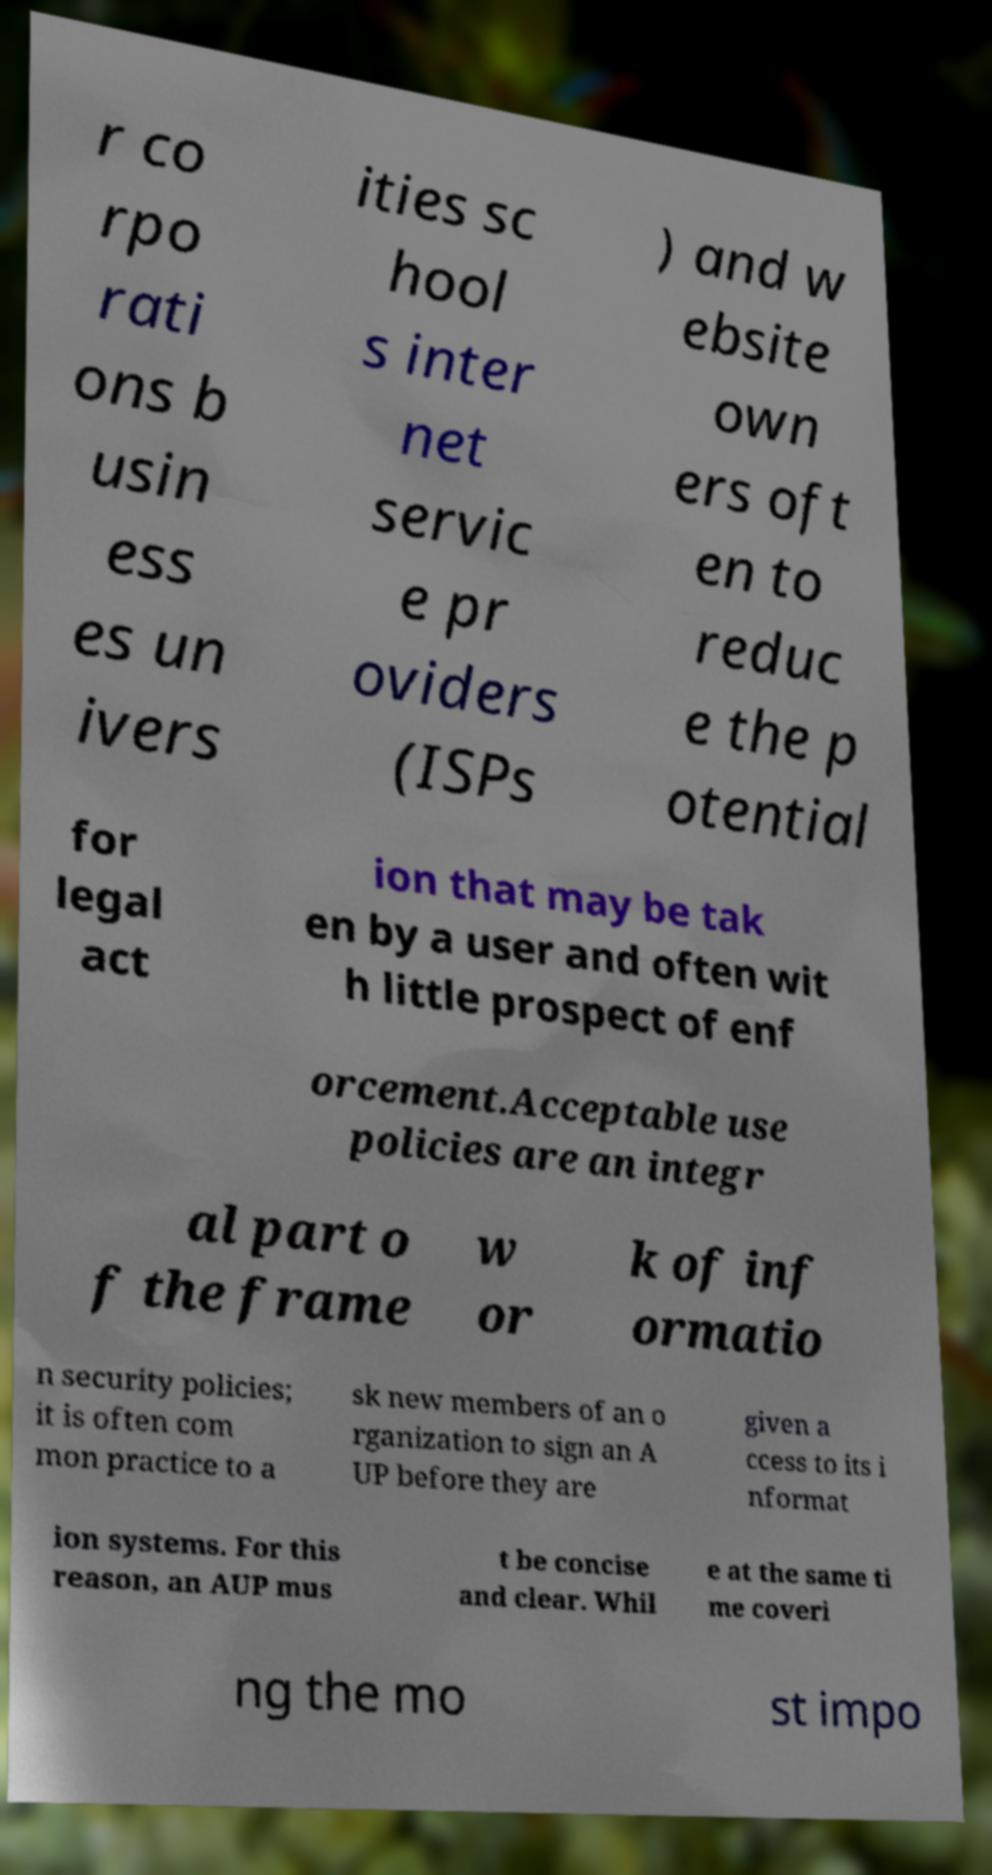Please identify and transcribe the text found in this image. r co rpo rati ons b usin ess es un ivers ities sc hool s inter net servic e pr oviders (ISPs ) and w ebsite own ers oft en to reduc e the p otential for legal act ion that may be tak en by a user and often wit h little prospect of enf orcement.Acceptable use policies are an integr al part o f the frame w or k of inf ormatio n security policies; it is often com mon practice to a sk new members of an o rganization to sign an A UP before they are given a ccess to its i nformat ion systems. For this reason, an AUP mus t be concise and clear. Whil e at the same ti me coveri ng the mo st impo 